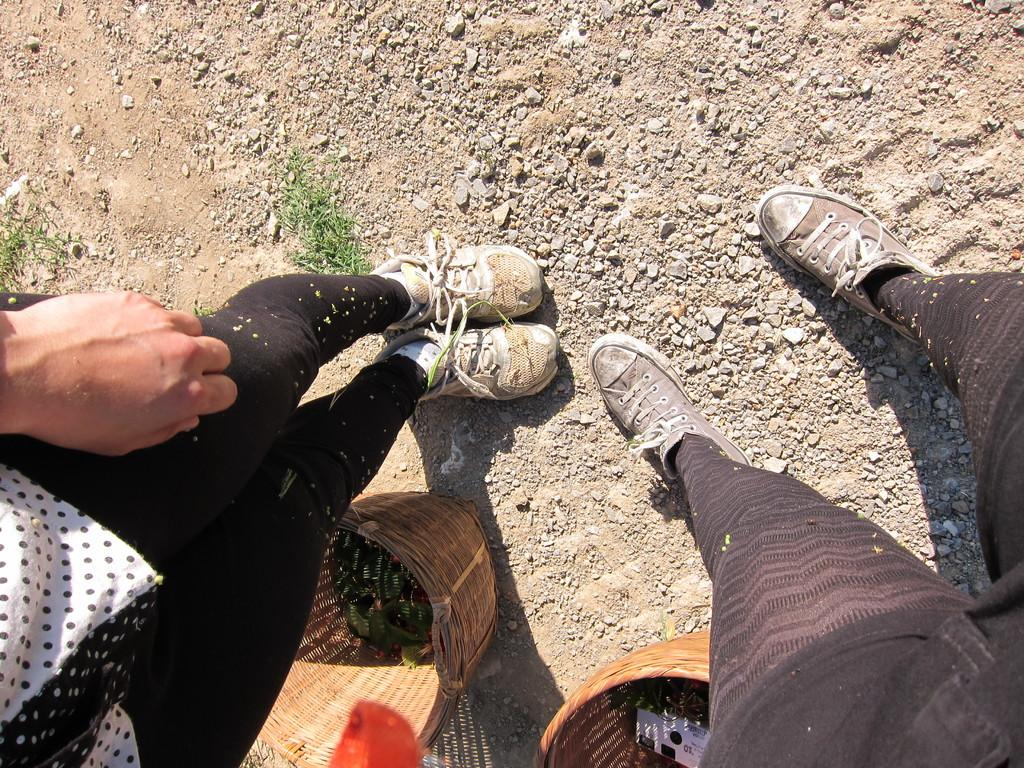How many people are present in the image? There are two persons in the image, as indicated by the presence of two sets of legs. What objects can be seen at the bottom of the image? There are two baskets at the bottom of the image. What type of natural elements are visible in the image? There are stones and grass visible in the image. What type of slope can be seen in the image? There is no slope present in the image; it features legs, baskets, stones, and grass. 